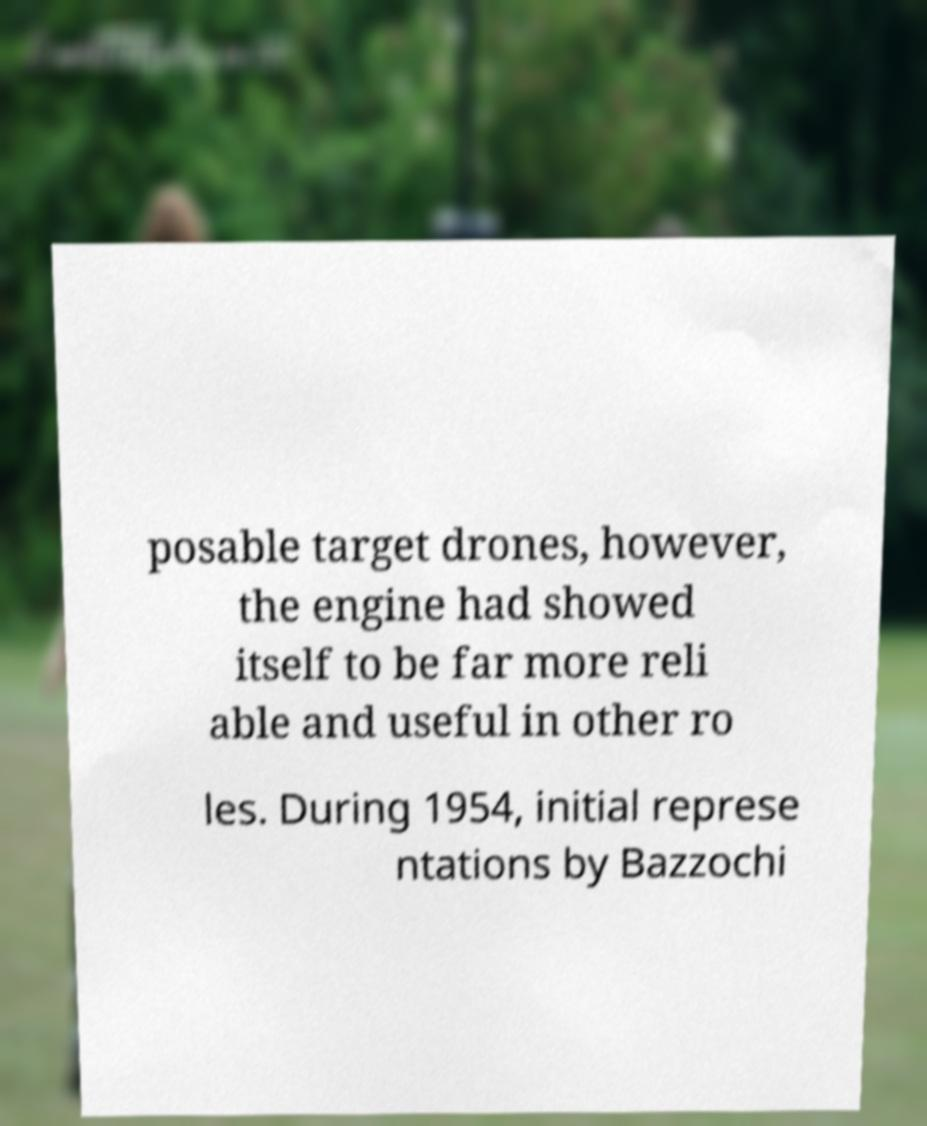For documentation purposes, I need the text within this image transcribed. Could you provide that? posable target drones, however, the engine had showed itself to be far more reli able and useful in other ro les. During 1954, initial represe ntations by Bazzochi 